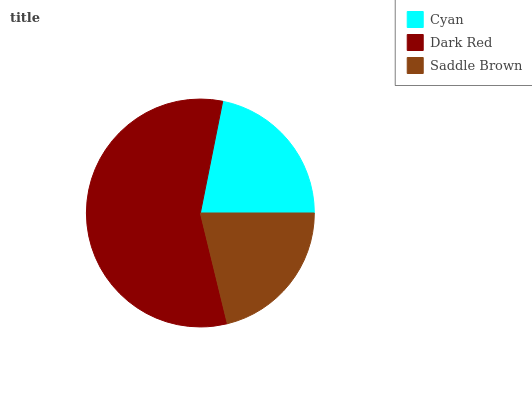Is Saddle Brown the minimum?
Answer yes or no. Yes. Is Dark Red the maximum?
Answer yes or no. Yes. Is Dark Red the minimum?
Answer yes or no. No. Is Saddle Brown the maximum?
Answer yes or no. No. Is Dark Red greater than Saddle Brown?
Answer yes or no. Yes. Is Saddle Brown less than Dark Red?
Answer yes or no. Yes. Is Saddle Brown greater than Dark Red?
Answer yes or no. No. Is Dark Red less than Saddle Brown?
Answer yes or no. No. Is Cyan the high median?
Answer yes or no. Yes. Is Cyan the low median?
Answer yes or no. Yes. Is Dark Red the high median?
Answer yes or no. No. Is Dark Red the low median?
Answer yes or no. No. 